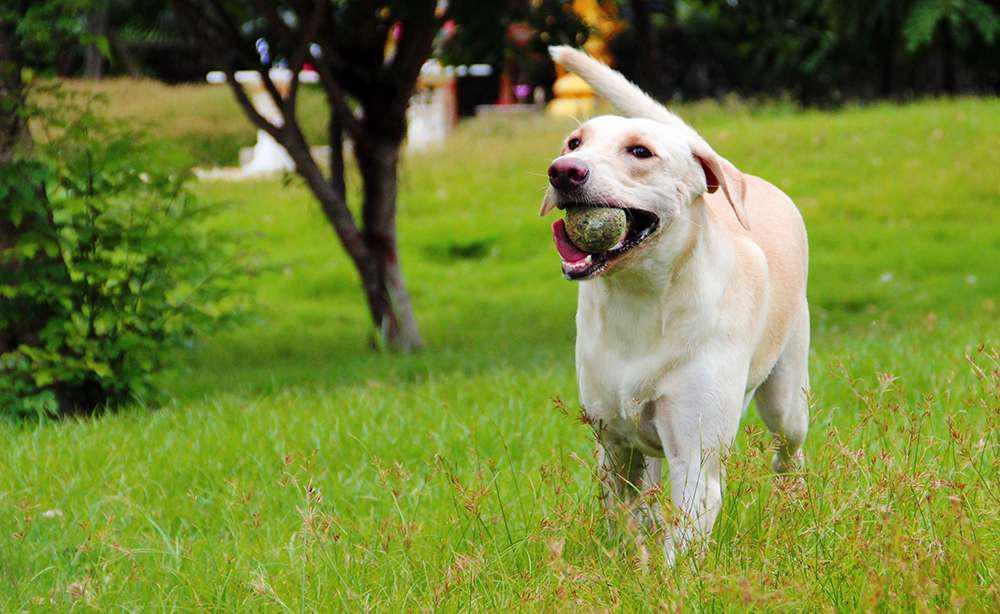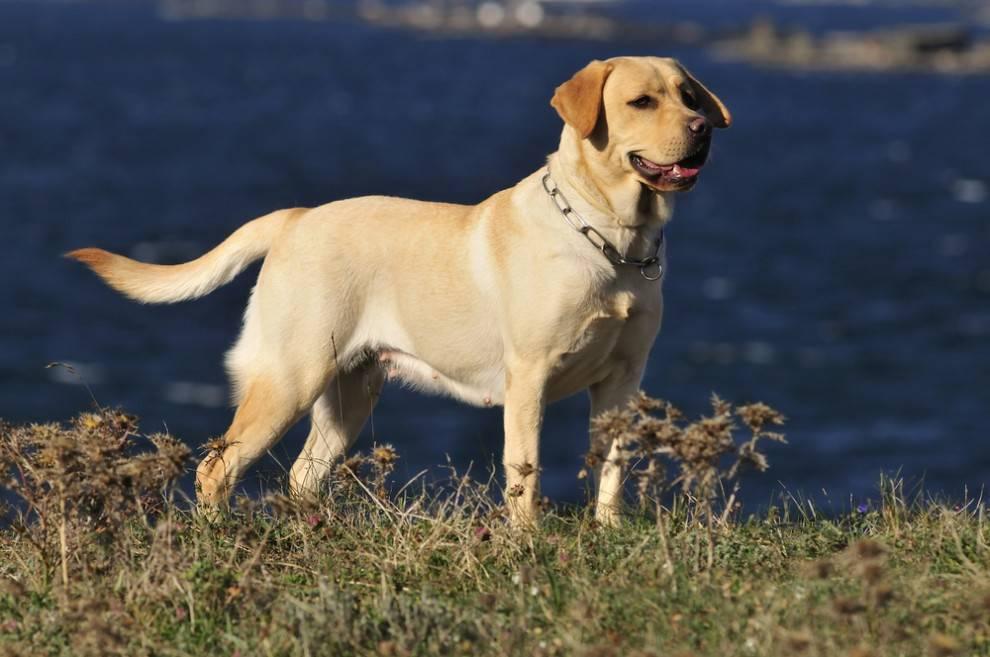The first image is the image on the left, the second image is the image on the right. Given the left and right images, does the statement "An image shows a standing dog with an open mouth and a collar around its neck." hold true? Answer yes or no. Yes. The first image is the image on the left, the second image is the image on the right. Given the left and right images, does the statement "One of the dogs is lying down and looking at the camera." hold true? Answer yes or no. No. 